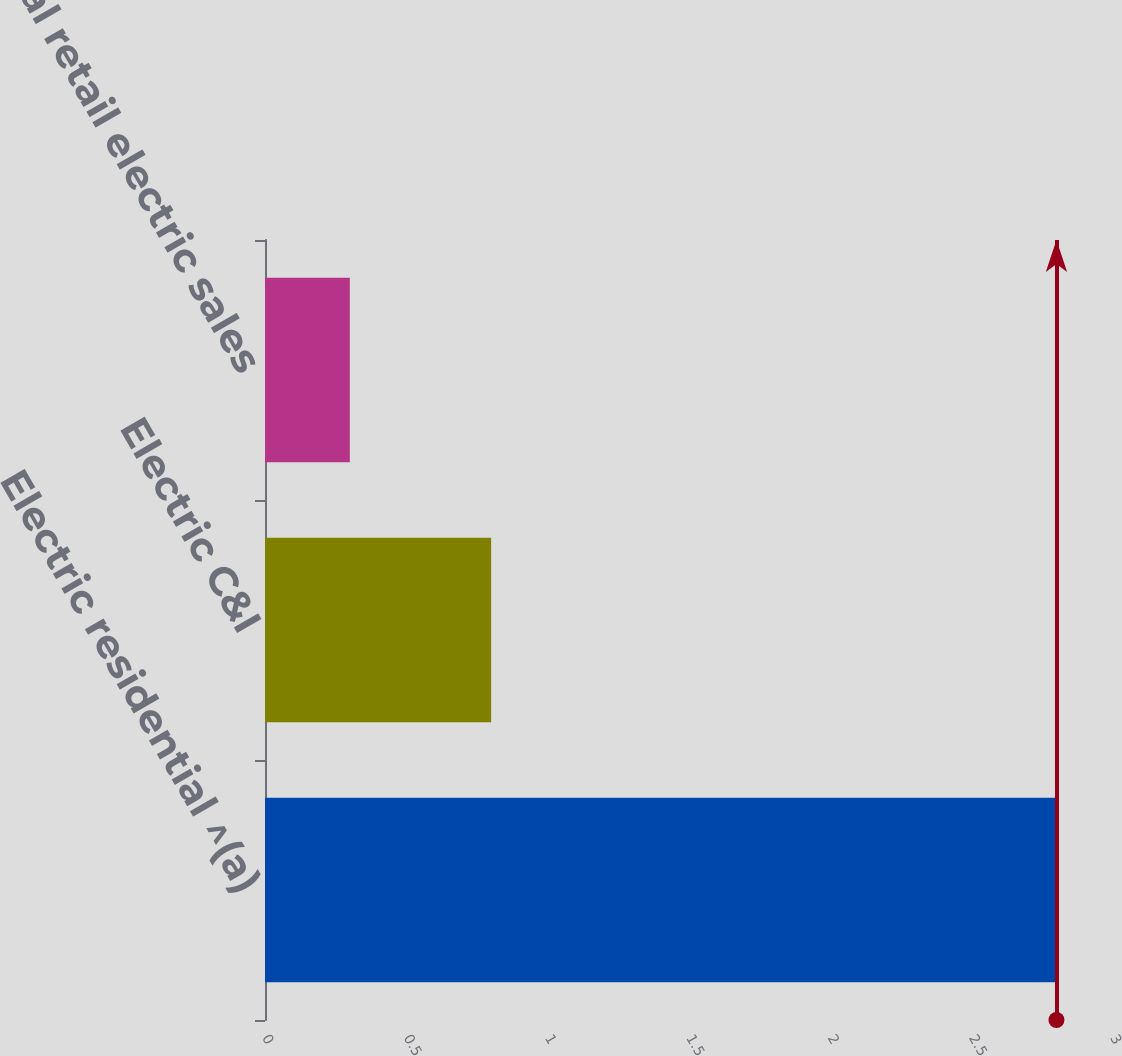Convert chart to OTSL. <chart><loc_0><loc_0><loc_500><loc_500><bar_chart><fcel>Electric residential ^(a)<fcel>Electric C&I<fcel>Total retail electric sales<nl><fcel>2.8<fcel>0.8<fcel>0.3<nl></chart> 